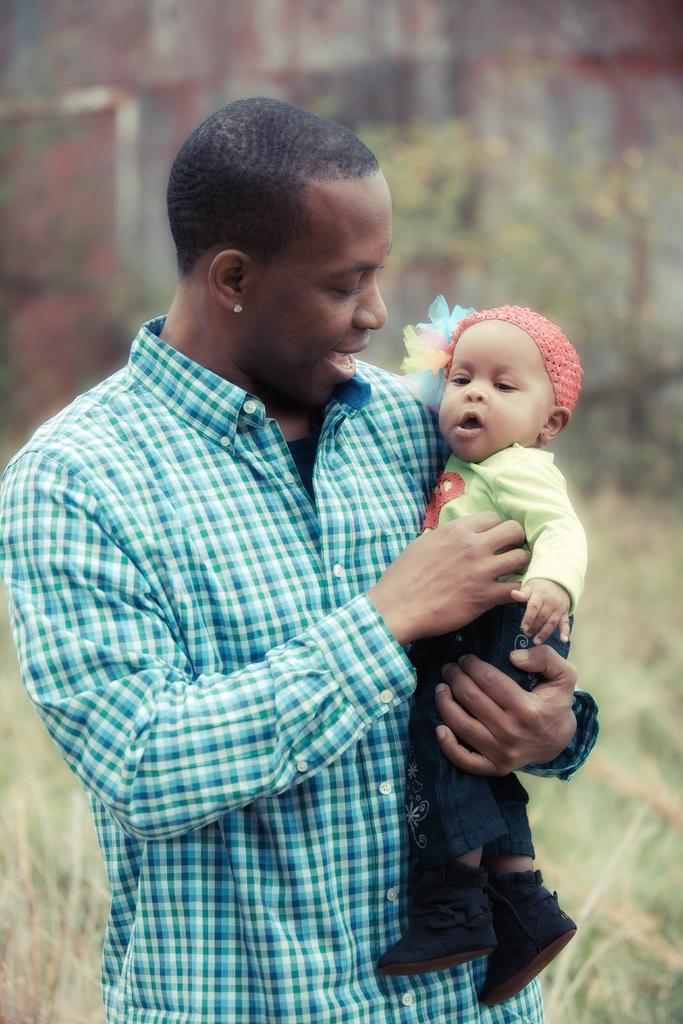Who is present in the image? There is a man in the image. What is the man doing in the image? The man is standing and holding a child. What type of vegetation can be seen in the image? There are plants and grass visible in the image. Can you tell me how many giraffes are visible in the image? There are no giraffes present in the image. What type of calendar is hanging on the wall in the image? There is no wall or calendar visible in the image. 